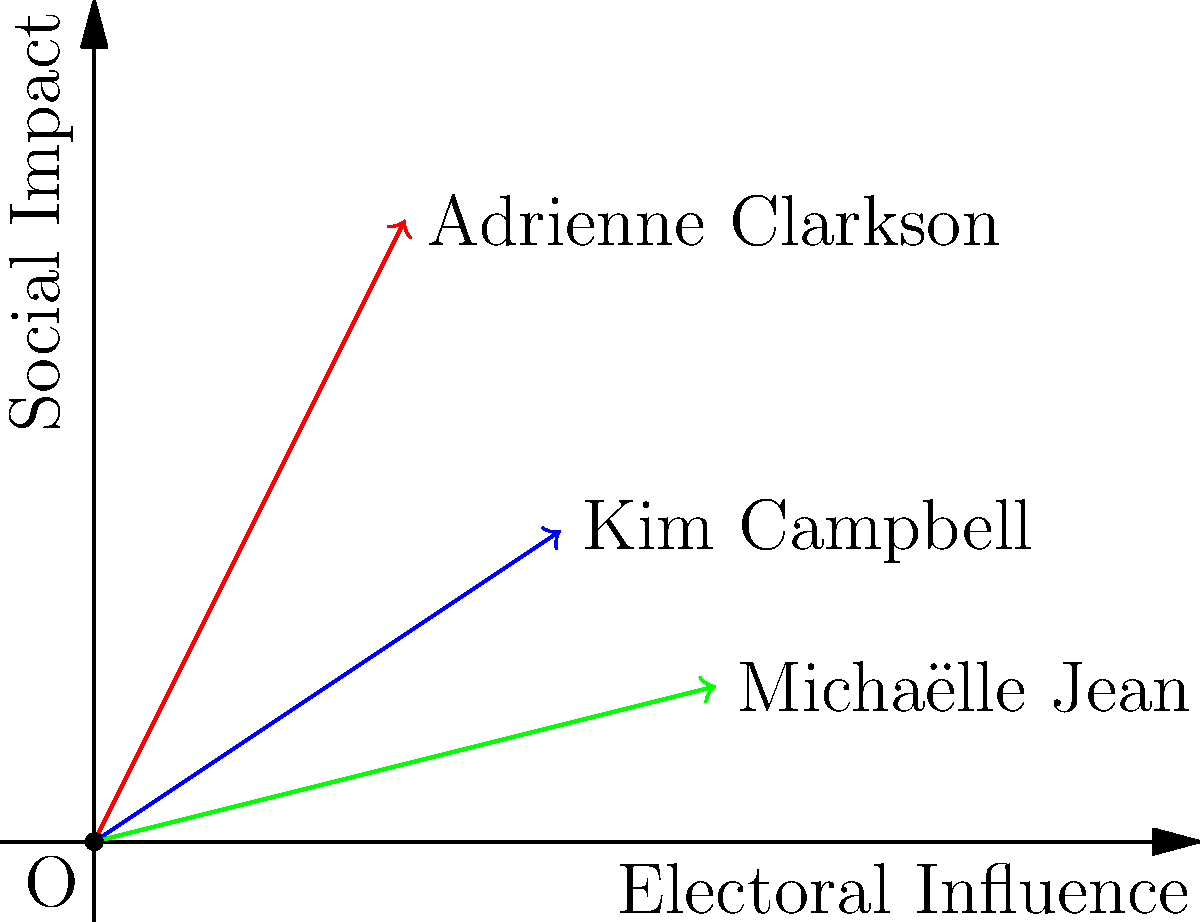In the vector force diagram above, three influential women in Canadian politics are represented: Kim Campbell, Adrienne Clarkson, and Michaëlle Jean. Their vectors are plotted on a grid where the x-axis represents electoral influence and the y-axis represents social impact. Based on the relative positions and magnitudes of these vectors, which of these women had the greatest overall influence (represented by the longest vector) in Canadian politics? To determine which woman had the greatest overall influence, we need to calculate the magnitude of each vector using the Pythagorean theorem. The magnitude represents the overall influence, combining both electoral influence (x-axis) and social impact (y-axis).

1. Kim Campbell (blue vector):
   Coordinates: (3, 2)
   Magnitude = $\sqrt{3^2 + 2^2} = \sqrt{13} \approx 3.61$

2. Adrienne Clarkson (red vector):
   Coordinates: (2, 4)
   Magnitude = $\sqrt{2^2 + 4^2} = \sqrt{20} \approx 4.47$

3. Michaëlle Jean (green vector):
   Coordinates: (4, 1)
   Magnitude = $\sqrt{4^2 + 1^2} = \sqrt{17} \approx 4.12$

Comparing the magnitudes:
Adrienne Clarkson (4.47) > Michaëlle Jean (4.12) > Kim Campbell (3.61)

Therefore, based on this representation, Adrienne Clarkson had the greatest overall influence in Canadian politics among the three women.
Answer: Adrienne Clarkson 